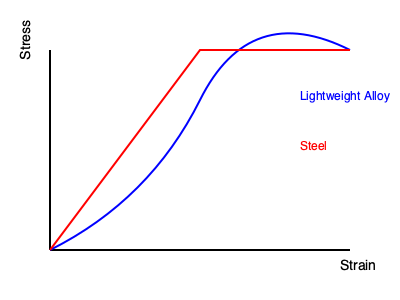Based on the stress-strain curves shown in the graph, which material would be more suitable for automotive components that need to absorb energy during a crash, and why? To answer this question, we need to analyze the stress-strain curves for both materials:

1. The blue curve represents the lightweight alloy, while the red curve represents steel.

2. Key observations:
   a) The lightweight alloy has a more curved stress-strain relationship.
   b) Steel has a more linear relationship followed by a flat region.

3. Energy absorption is related to the area under the stress-strain curve. A larger area indicates more energy absorption capacity.

4. The lightweight alloy's curve encloses a larger area, suggesting it can absorb more energy before failure.

5. In automotive design, components that absorb energy during a crash help protect passengers by dissipating the impact force.

6. The lightweight alloy's ability to undergo more deformation (strain) while sustaining stress makes it better suited for energy absorption in crash scenarios.

7. Additionally, the gradual increase in stress for the alloy indicates a more controlled deformation process, which is beneficial in crash energy management.

Therefore, the lightweight alloy would be more suitable for automotive components designed to absorb energy during a crash due to its superior energy absorption characteristics as shown by its stress-strain curve.
Answer: Lightweight alloy, due to greater energy absorption capacity. 